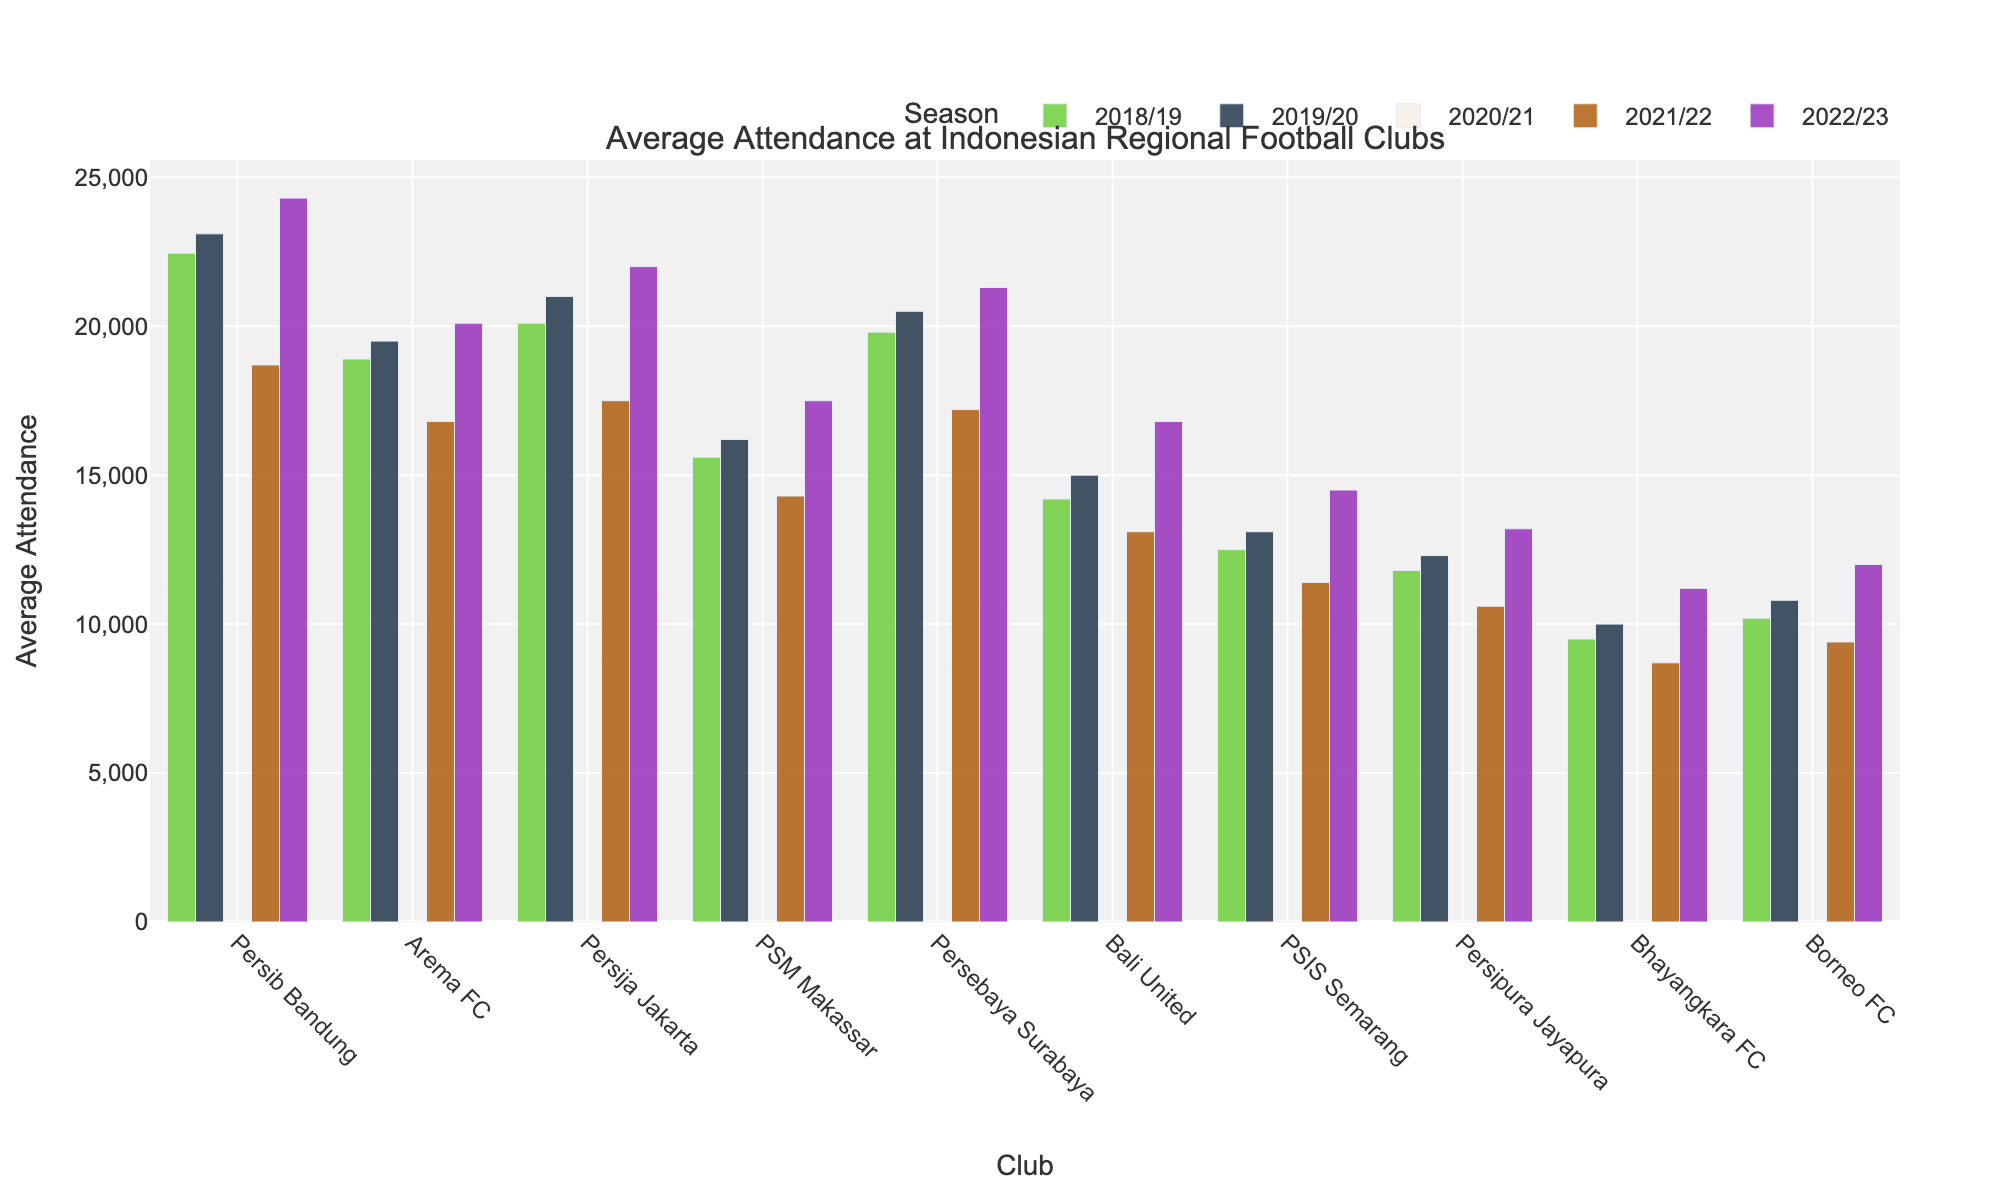Which club had the highest average attendance in the 2018/19 season? By examining the bars corresponding to the 2018/19 season, the tallest bar represents the highest average attendance. Persib Bandung shows the tallest bar for 2018/19.
Answer: Persib Bandung Which club has the lowest average attendance in the 2022/23 season? By checking the bars for the 2022/23 season, the shortest bar represents the lowest average attendance. Bhayangkara FC has the shortest bar for 2022/23.
Answer: Bhayangkara FC What's the difference in average attendance between Persib Bandung and Arema FC in the 2022/23 season? First, find the average attendance for Persib Bandung in 2022/23 (24300) and Arema FC in the same season (20100). The difference is 24300 - 20100 = 4200.
Answer: 4200 Which club showed the most significant increase in attendance from 2021/22 to 2022/23? Calculate the increase for each club by subtracting their 2021/22 attendance from their 2022/23 attendance, and find the largest difference. Persebaya Surabaya had an increase of 21300 - 17200 = 4100, which is the largest.
Answer: Persebaya Surabaya What was the total attendance for PSIS Semarang across all seasons shown? Sum the attendance numbers for PSIS Semarang: 12500 + 13100 + 0 + 11400 + 14500 = 51500.
Answer: 51500 Which club had a decrease in average attendance from the 2018/19 season to the 2019/20 season? Compare the bars for each club between the 2018/19 and 2019/20 seasons. Bali United had a lower attendance in 2019/20 (15000) compared to 2018/19 (14200), indicating a decrease.
Answer: Bali United How did the average attendance for PSM Makassar change from the 2018/19 season to the 2022/23 season? Compare the average attendance in 2018/19 (15600) with that in 2022/23 (17500). The change is 17500 - 15600 = 1900 increase.
Answer: Increased by 1900 Which two clubs had the closest average attendance in the 2019/20 season? Compare the bars for 2019/20 and find the two bars that are closest in height. Persija Jakarta (21000) and Persebaya Surabaya (20500) are closest with a difference of 500.
Answer: Persija Jakarta and Persebaya Surabaya What was the overall trend for average attendance from 2018/19 to 2022/23 for Bali United? Observe the bar heights for Bali United across the seasons. It starts at 14200 in 2018/19, increases slightly to 15000 in 2019/20, drops to 0 in 2020/21, decreases to 13100 in 2021/22, and then increases to 16800 in 2022/23. The overall trend is initially rising, then dropping significantly, followed by a recovery.
Answer: Rising, then dropping, recovering 